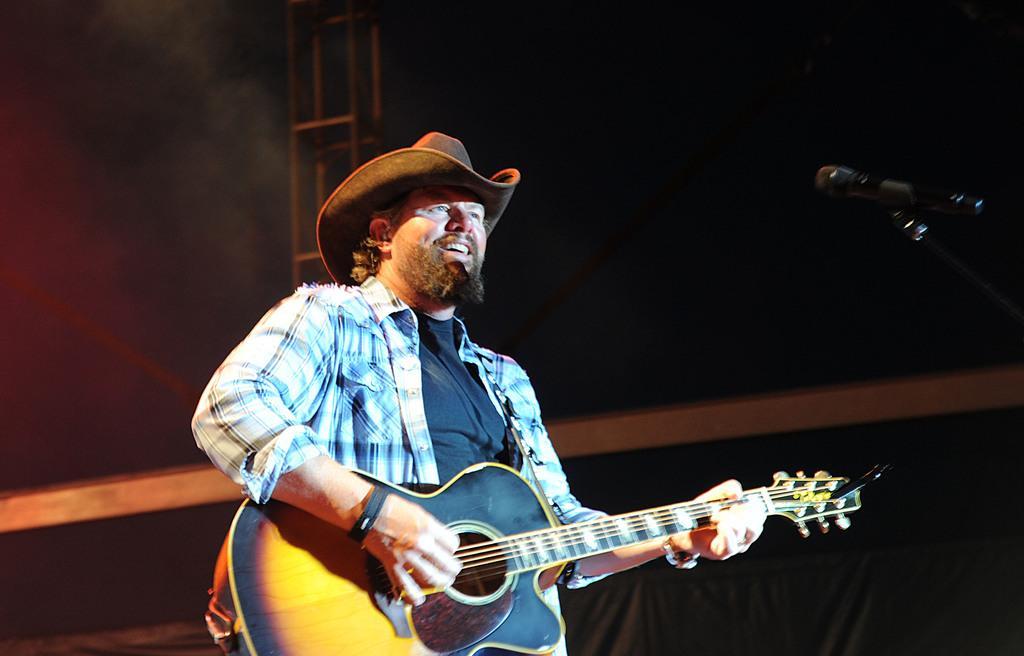Can you describe this image briefly? This person is playing a guitar. This person wore shirt and hat. This is mic with holder. 